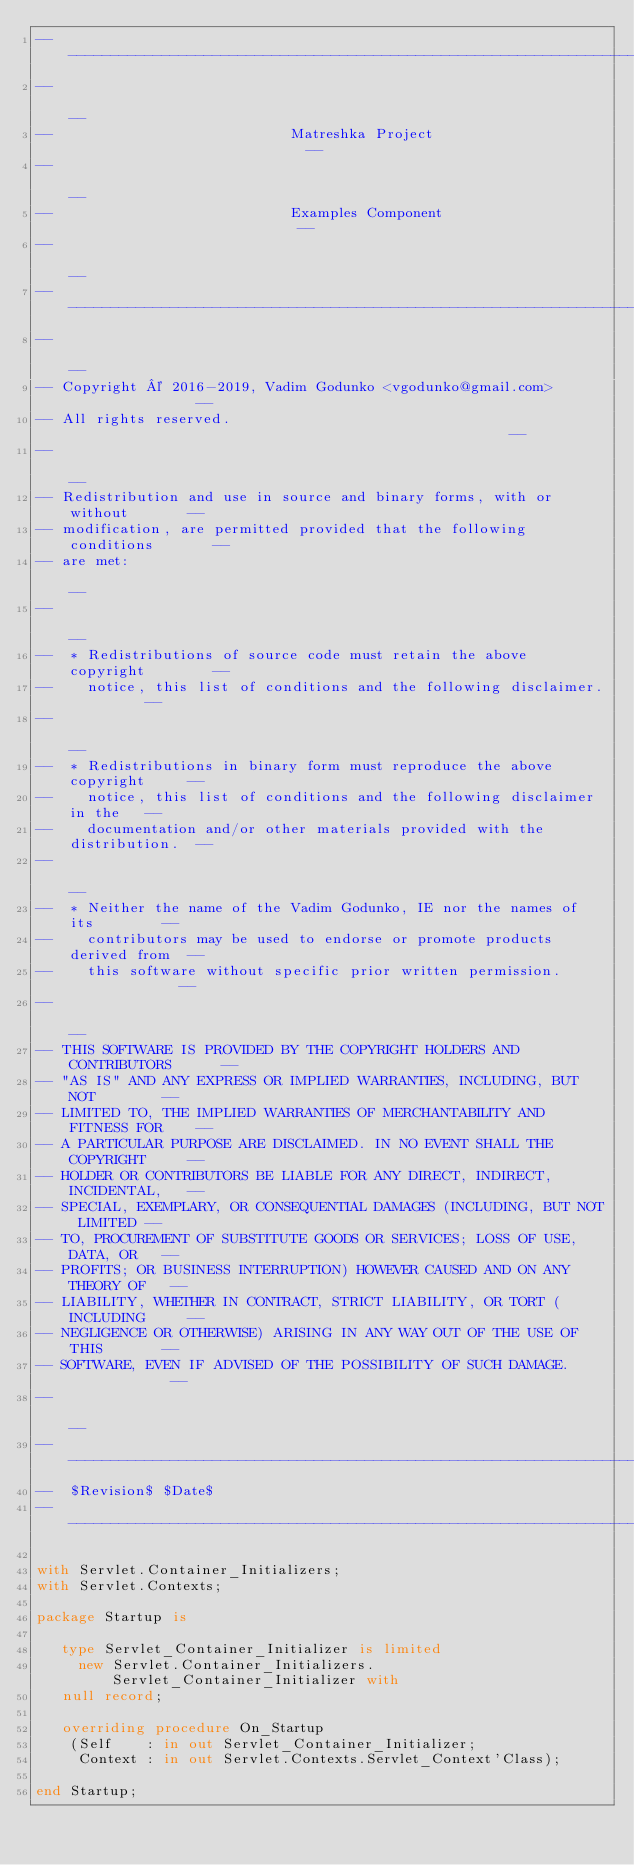<code> <loc_0><loc_0><loc_500><loc_500><_Ada_>------------------------------------------------------------------------------
--                                                                          --
--                            Matreshka Project                             --
--                                                                          --
--                            Examples Component                            --
--                                                                          --
------------------------------------------------------------------------------
--                                                                          --
-- Copyright © 2016-2019, Vadim Godunko <vgodunko@gmail.com>                --
-- All rights reserved.                                                     --
--                                                                          --
-- Redistribution and use in source and binary forms, with or without       --
-- modification, are permitted provided that the following conditions       --
-- are met:                                                                 --
--                                                                          --
--  * Redistributions of source code must retain the above copyright        --
--    notice, this list of conditions and the following disclaimer.         --
--                                                                          --
--  * Redistributions in binary form must reproduce the above copyright     --
--    notice, this list of conditions and the following disclaimer in the   --
--    documentation and/or other materials provided with the distribution.  --
--                                                                          --
--  * Neither the name of the Vadim Godunko, IE nor the names of its        --
--    contributors may be used to endorse or promote products derived from  --
--    this software without specific prior written permission.              --
--                                                                          --
-- THIS SOFTWARE IS PROVIDED BY THE COPYRIGHT HOLDERS AND CONTRIBUTORS      --
-- "AS IS" AND ANY EXPRESS OR IMPLIED WARRANTIES, INCLUDING, BUT NOT        --
-- LIMITED TO, THE IMPLIED WARRANTIES OF MERCHANTABILITY AND FITNESS FOR    --
-- A PARTICULAR PURPOSE ARE DISCLAIMED. IN NO EVENT SHALL THE COPYRIGHT     --
-- HOLDER OR CONTRIBUTORS BE LIABLE FOR ANY DIRECT, INDIRECT, INCIDENTAL,   --
-- SPECIAL, EXEMPLARY, OR CONSEQUENTIAL DAMAGES (INCLUDING, BUT NOT LIMITED --
-- TO, PROCUREMENT OF SUBSTITUTE GOODS OR SERVICES; LOSS OF USE, DATA, OR   --
-- PROFITS; OR BUSINESS INTERRUPTION) HOWEVER CAUSED AND ON ANY THEORY OF   --
-- LIABILITY, WHETHER IN CONTRACT, STRICT LIABILITY, OR TORT (INCLUDING     --
-- NEGLIGENCE OR OTHERWISE) ARISING IN ANY WAY OUT OF THE USE OF THIS       --
-- SOFTWARE, EVEN IF ADVISED OF THE POSSIBILITY OF SUCH DAMAGE.             --
--                                                                          --
------------------------------------------------------------------------------
--  $Revision$ $Date$
------------------------------------------------------------------------------

with Servlet.Container_Initializers;
with Servlet.Contexts;

package Startup is

   type Servlet_Container_Initializer is limited
     new Servlet.Container_Initializers.Servlet_Container_Initializer with
   null record;

   overriding procedure On_Startup
    (Self    : in out Servlet_Container_Initializer;
     Context : in out Servlet.Contexts.Servlet_Context'Class);

end Startup;
</code> 